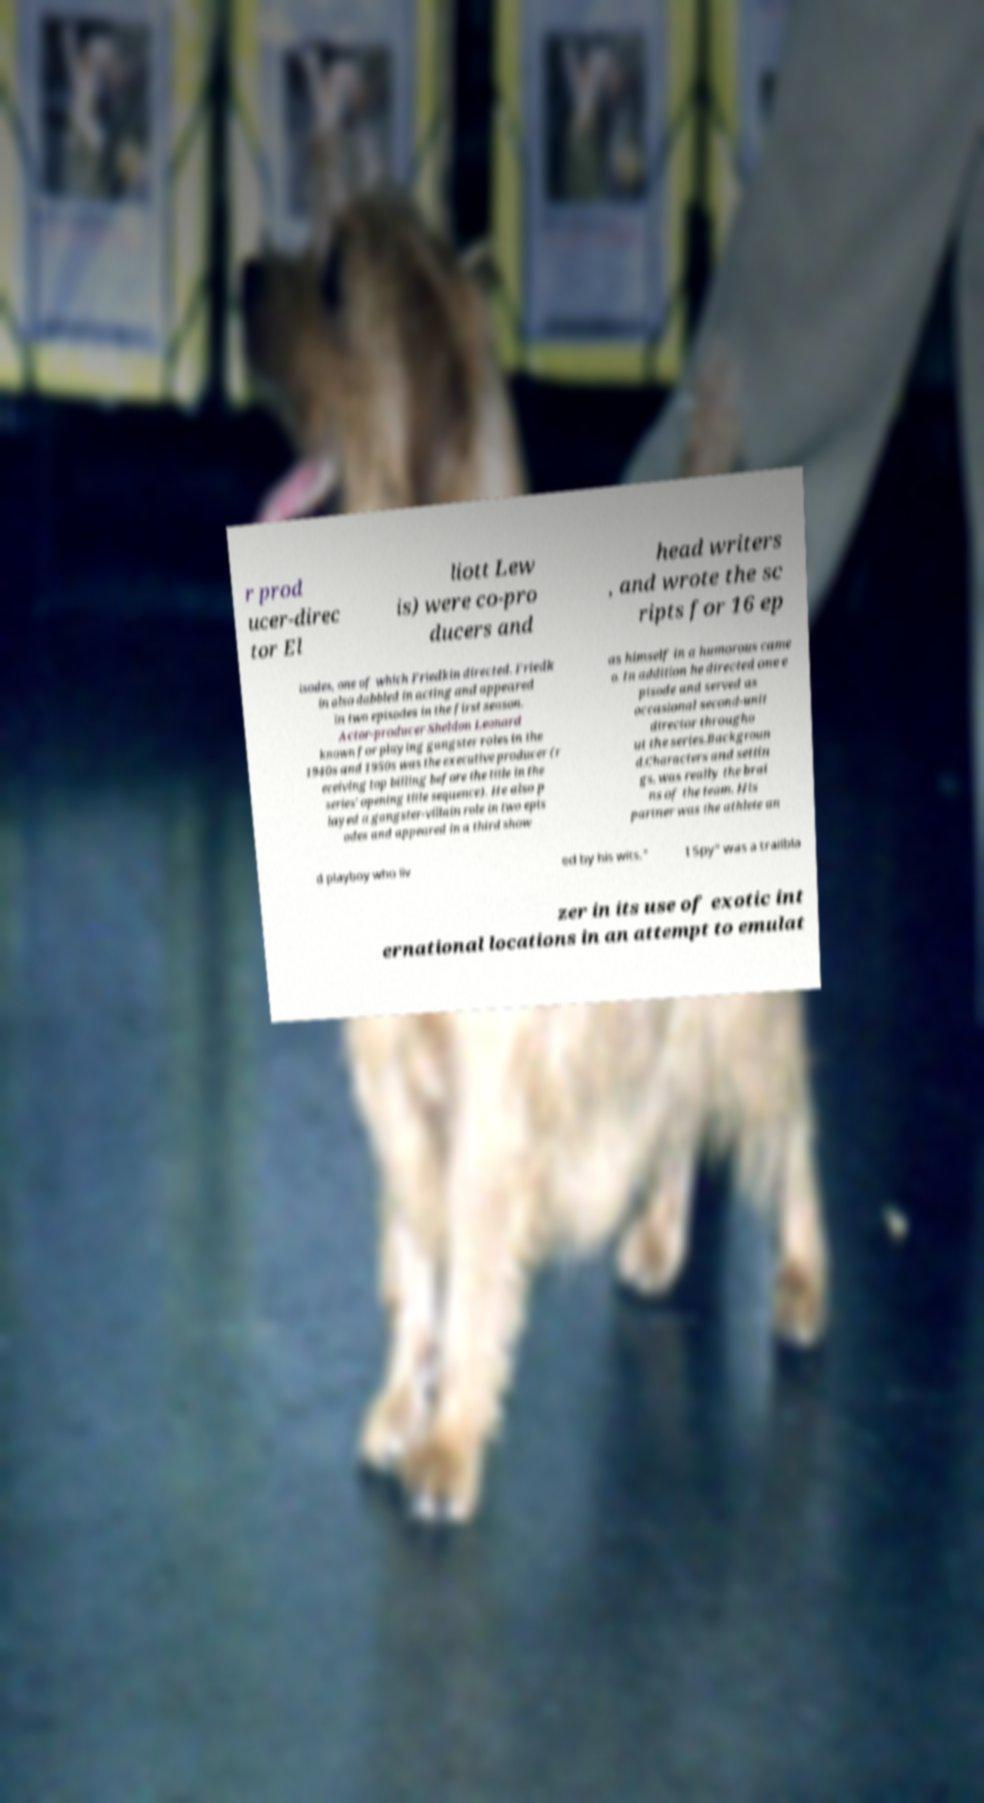Could you assist in decoding the text presented in this image and type it out clearly? r prod ucer-direc tor El liott Lew is) were co-pro ducers and head writers , and wrote the sc ripts for 16 ep isodes, one of which Friedkin directed. Friedk in also dabbled in acting and appeared in two episodes in the first season. Actor-producer Sheldon Leonard known for playing gangster roles in the 1940s and 1950s was the executive producer (r eceiving top billing before the title in the series' opening title sequence). He also p layed a gangster-villain role in two epis odes and appeared in a third show as himself in a humorous came o. In addition he directed one e pisode and served as occasional second-unit director througho ut the series.Backgroun d.Characters and settin gs. was really the brai ns of the team. His partner was the athlete an d playboy who liv ed by his wits." I Spy" was a trailbla zer in its use of exotic int ernational locations in an attempt to emulat 